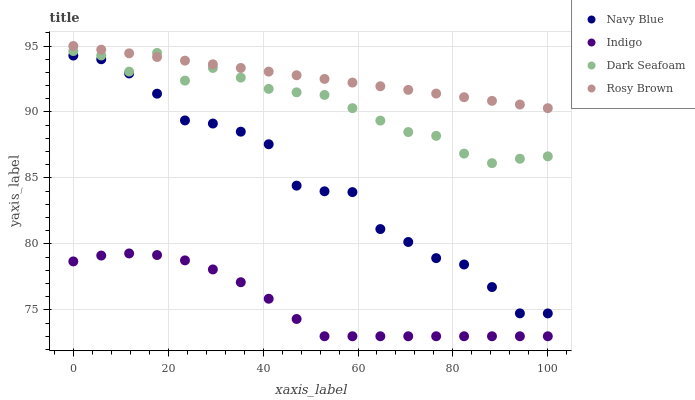Does Indigo have the minimum area under the curve?
Answer yes or no. Yes. Does Rosy Brown have the maximum area under the curve?
Answer yes or no. Yes. Does Dark Seafoam have the minimum area under the curve?
Answer yes or no. No. Does Dark Seafoam have the maximum area under the curve?
Answer yes or no. No. Is Rosy Brown the smoothest?
Answer yes or no. Yes. Is Navy Blue the roughest?
Answer yes or no. Yes. Is Dark Seafoam the smoothest?
Answer yes or no. No. Is Dark Seafoam the roughest?
Answer yes or no. No. Does Indigo have the lowest value?
Answer yes or no. Yes. Does Dark Seafoam have the lowest value?
Answer yes or no. No. Does Rosy Brown have the highest value?
Answer yes or no. Yes. Does Dark Seafoam have the highest value?
Answer yes or no. No. Is Indigo less than Navy Blue?
Answer yes or no. Yes. Is Rosy Brown greater than Indigo?
Answer yes or no. Yes. Does Rosy Brown intersect Dark Seafoam?
Answer yes or no. Yes. Is Rosy Brown less than Dark Seafoam?
Answer yes or no. No. Is Rosy Brown greater than Dark Seafoam?
Answer yes or no. No. Does Indigo intersect Navy Blue?
Answer yes or no. No. 